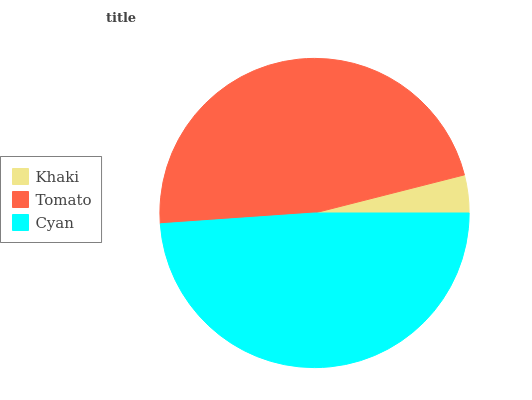Is Khaki the minimum?
Answer yes or no. Yes. Is Cyan the maximum?
Answer yes or no. Yes. Is Tomato the minimum?
Answer yes or no. No. Is Tomato the maximum?
Answer yes or no. No. Is Tomato greater than Khaki?
Answer yes or no. Yes. Is Khaki less than Tomato?
Answer yes or no. Yes. Is Khaki greater than Tomato?
Answer yes or no. No. Is Tomato less than Khaki?
Answer yes or no. No. Is Tomato the high median?
Answer yes or no. Yes. Is Tomato the low median?
Answer yes or no. Yes. Is Khaki the high median?
Answer yes or no. No. Is Khaki the low median?
Answer yes or no. No. 